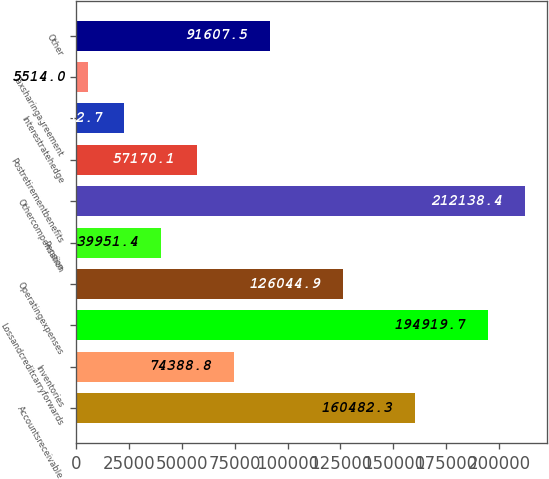<chart> <loc_0><loc_0><loc_500><loc_500><bar_chart><fcel>Accountsreceivable<fcel>Inventories<fcel>Lossandcreditcarryforwards<fcel>Operatingexpenses<fcel>Pension<fcel>Othercompensation<fcel>Postretirementbenefits<fcel>Interestratehedge<fcel>Taxsharingagreement<fcel>Other<nl><fcel>160482<fcel>74388.8<fcel>194920<fcel>126045<fcel>39951.4<fcel>212138<fcel>57170.1<fcel>22732.7<fcel>5514<fcel>91607.5<nl></chart> 